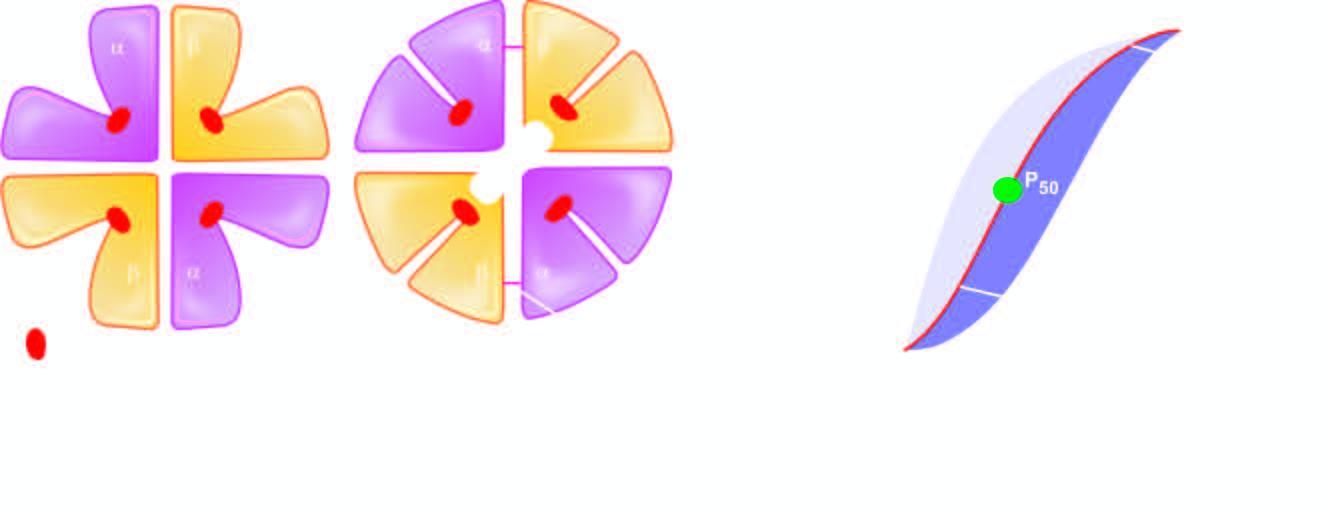what are formed again?
Answer the question using a single word or phrase. Salt bridge 